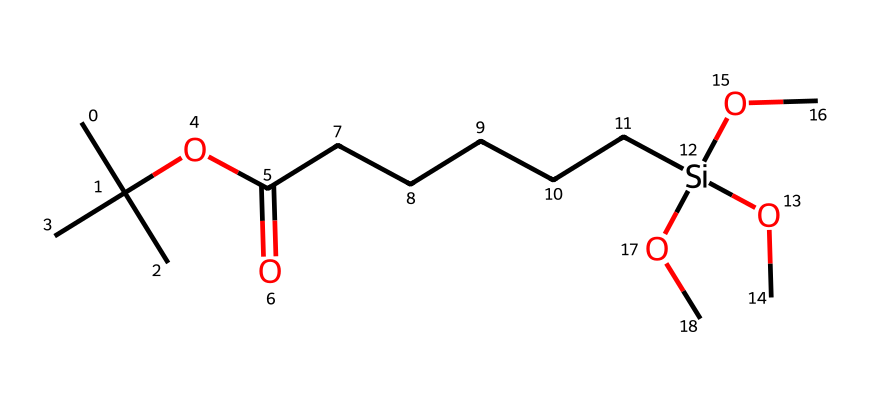what is the total number of carbon atoms in this compound? The SMILES representation indicates there are six carbon atoms from the side branched alkyl groups and one carbon from the carbonyl group (C=O), totaling seven carbons in the entire structure.
Answer: seven how many oxygen atoms are present in the molecule? In the provided SMILES, there are three occurrences of the oxygen atom in the ether and one in the ester, totaling four oxygen atoms in the molecule.
Answer: four which functional group is present in this chemical? The presence of the carbonyl group (C=O) along with the alkoxy groups -OCH3 indicates that this compound contains an ester functional group.
Answer: ester what type of silane is present in this structure? The presence of multiple alkoxy groups attached to silicon indicates this is a trialkoxysilane, specifically a triethoxysilane due to the three -OCH3 groups attached to silicon.
Answer: trialkoxysilane how many silicon atoms are in this molecule? There is one silicon atom indicated in the SMILES representation, which is linked to several oxygen functionalities, making it a silane-based compound.
Answer: one is there a hydrophobic or hydrophilic nature based on the structure? The presence of long alkyl chains suggests the molecule is more hydrophobic due to its large non-polar sections, despite the presence of polar functional groups.
Answer: hydrophobic what would be the expected use of this compound in drug delivery systems? Given its silane-modified nature and functional groups, this compound likely serves as a carrier for drug molecules, aiding in formulation stability and delivery efficiency.
Answer: drug carrier 